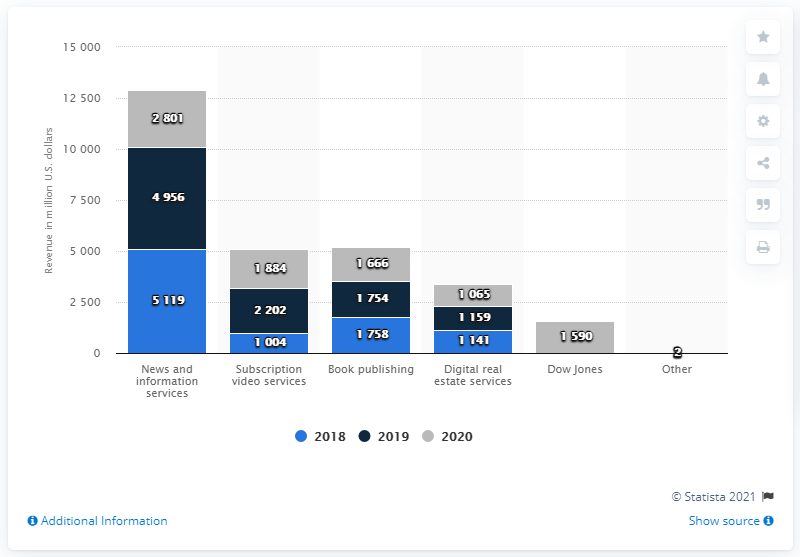Give some essential details in this illustration. In 2020, News Corp. generated approximately $2801 million in revenue. 